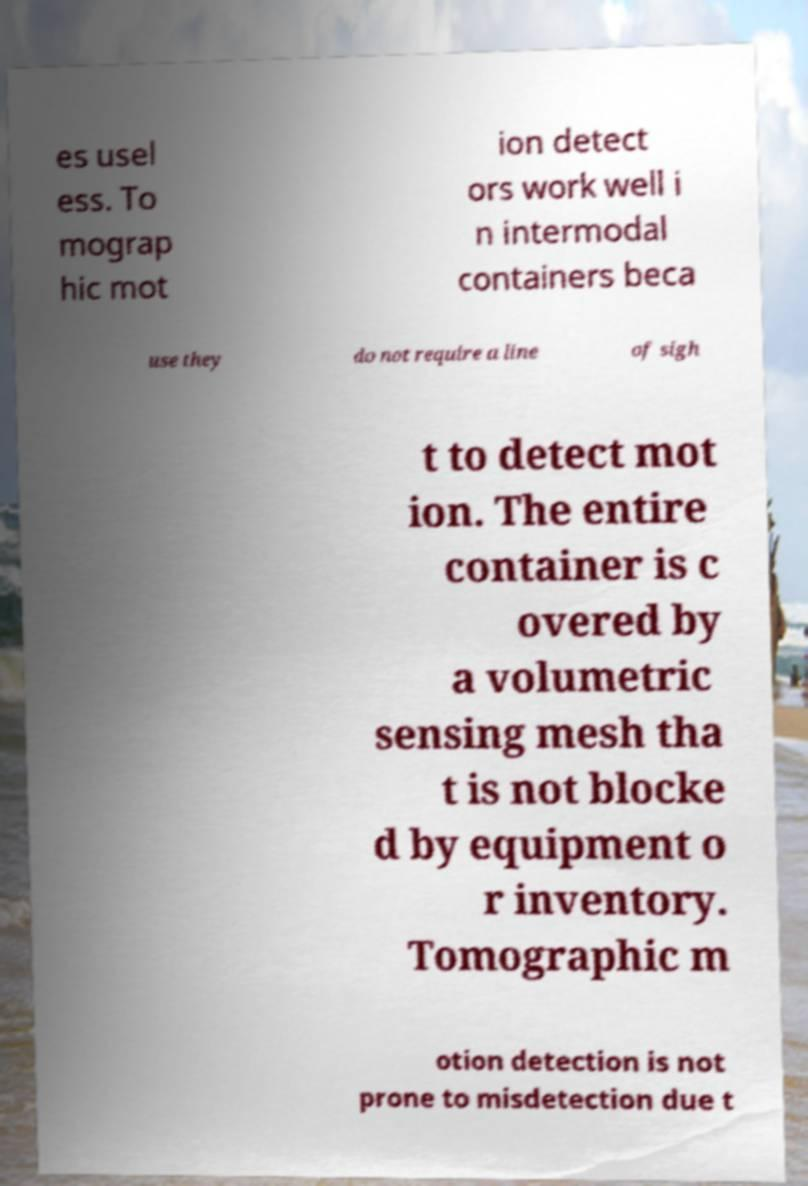What messages or text are displayed in this image? I need them in a readable, typed format. es usel ess. To mograp hic mot ion detect ors work well i n intermodal containers beca use they do not require a line of sigh t to detect mot ion. The entire container is c overed by a volumetric sensing mesh tha t is not blocke d by equipment o r inventory. Tomographic m otion detection is not prone to misdetection due t 